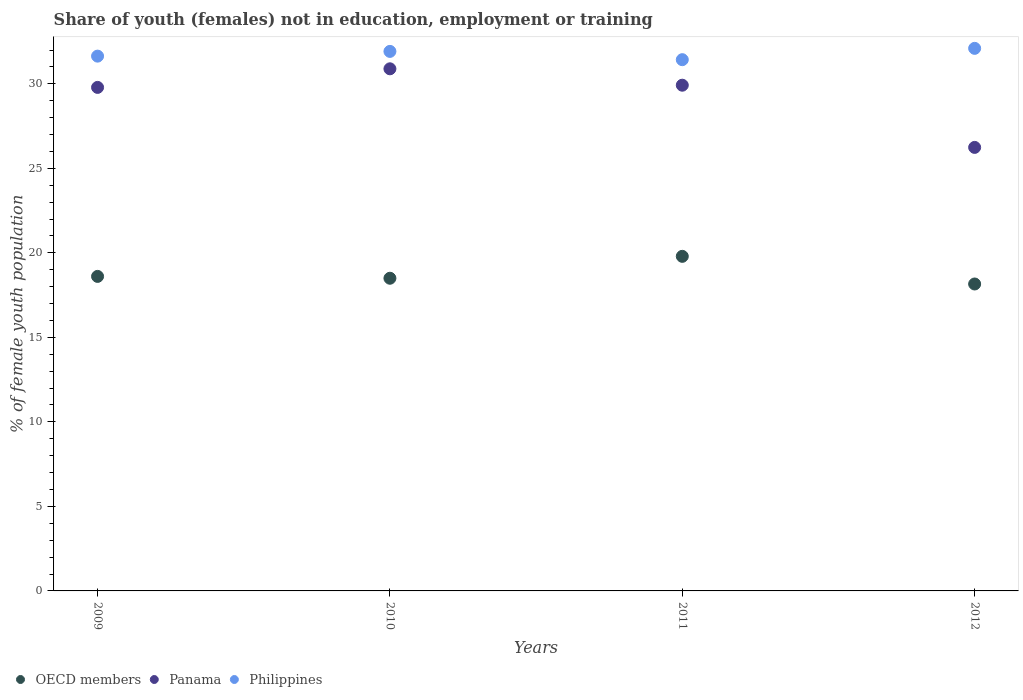How many different coloured dotlines are there?
Provide a short and direct response. 3. What is the percentage of unemployed female population in in OECD members in 2012?
Your answer should be compact. 18.16. Across all years, what is the maximum percentage of unemployed female population in in Panama?
Your answer should be compact. 30.89. Across all years, what is the minimum percentage of unemployed female population in in Philippines?
Give a very brief answer. 31.43. What is the total percentage of unemployed female population in in Philippines in the graph?
Make the answer very short. 127.09. What is the difference between the percentage of unemployed female population in in OECD members in 2011 and that in 2012?
Offer a very short reply. 1.64. What is the difference between the percentage of unemployed female population in in Philippines in 2012 and the percentage of unemployed female population in in Panama in 2009?
Provide a short and direct response. 2.31. What is the average percentage of unemployed female population in in OECD members per year?
Provide a succinct answer. 18.77. In the year 2009, what is the difference between the percentage of unemployed female population in in OECD members and percentage of unemployed female population in in Panama?
Make the answer very short. -11.18. In how many years, is the percentage of unemployed female population in in Philippines greater than 4 %?
Provide a succinct answer. 4. What is the ratio of the percentage of unemployed female population in in Philippines in 2011 to that in 2012?
Provide a succinct answer. 0.98. Is the difference between the percentage of unemployed female population in in OECD members in 2011 and 2012 greater than the difference between the percentage of unemployed female population in in Panama in 2011 and 2012?
Provide a succinct answer. No. What is the difference between the highest and the second highest percentage of unemployed female population in in Panama?
Provide a succinct answer. 0.97. What is the difference between the highest and the lowest percentage of unemployed female population in in Philippines?
Provide a succinct answer. 0.67. In how many years, is the percentage of unemployed female population in in OECD members greater than the average percentage of unemployed female population in in OECD members taken over all years?
Your response must be concise. 1. Is the sum of the percentage of unemployed female population in in Panama in 2009 and 2011 greater than the maximum percentage of unemployed female population in in Philippines across all years?
Keep it short and to the point. Yes. Does the percentage of unemployed female population in in Panama monotonically increase over the years?
Provide a short and direct response. No. How many dotlines are there?
Ensure brevity in your answer.  3. What is the difference between two consecutive major ticks on the Y-axis?
Keep it short and to the point. 5. Are the values on the major ticks of Y-axis written in scientific E-notation?
Your response must be concise. No. Does the graph contain any zero values?
Provide a short and direct response. No. Does the graph contain grids?
Provide a short and direct response. No. What is the title of the graph?
Your answer should be very brief. Share of youth (females) not in education, employment or training. What is the label or title of the Y-axis?
Provide a succinct answer. % of female youth population. What is the % of female youth population in OECD members in 2009?
Provide a succinct answer. 18.61. What is the % of female youth population in Panama in 2009?
Provide a short and direct response. 29.79. What is the % of female youth population in Philippines in 2009?
Provide a succinct answer. 31.64. What is the % of female youth population in OECD members in 2010?
Keep it short and to the point. 18.5. What is the % of female youth population in Panama in 2010?
Your response must be concise. 30.89. What is the % of female youth population in Philippines in 2010?
Your answer should be compact. 31.92. What is the % of female youth population of OECD members in 2011?
Offer a terse response. 19.8. What is the % of female youth population in Panama in 2011?
Your response must be concise. 29.92. What is the % of female youth population of Philippines in 2011?
Make the answer very short. 31.43. What is the % of female youth population of OECD members in 2012?
Your answer should be compact. 18.16. What is the % of female youth population of Panama in 2012?
Ensure brevity in your answer.  26.24. What is the % of female youth population in Philippines in 2012?
Offer a terse response. 32.1. Across all years, what is the maximum % of female youth population in OECD members?
Provide a succinct answer. 19.8. Across all years, what is the maximum % of female youth population in Panama?
Provide a succinct answer. 30.89. Across all years, what is the maximum % of female youth population of Philippines?
Make the answer very short. 32.1. Across all years, what is the minimum % of female youth population of OECD members?
Offer a very short reply. 18.16. Across all years, what is the minimum % of female youth population of Panama?
Your answer should be compact. 26.24. Across all years, what is the minimum % of female youth population of Philippines?
Your answer should be very brief. 31.43. What is the total % of female youth population in OECD members in the graph?
Provide a succinct answer. 75.06. What is the total % of female youth population of Panama in the graph?
Give a very brief answer. 116.84. What is the total % of female youth population in Philippines in the graph?
Your answer should be very brief. 127.09. What is the difference between the % of female youth population in OECD members in 2009 and that in 2010?
Provide a succinct answer. 0.11. What is the difference between the % of female youth population of Philippines in 2009 and that in 2010?
Offer a very short reply. -0.28. What is the difference between the % of female youth population of OECD members in 2009 and that in 2011?
Offer a terse response. -1.19. What is the difference between the % of female youth population in Panama in 2009 and that in 2011?
Offer a terse response. -0.13. What is the difference between the % of female youth population in Philippines in 2009 and that in 2011?
Your answer should be very brief. 0.21. What is the difference between the % of female youth population of OECD members in 2009 and that in 2012?
Ensure brevity in your answer.  0.45. What is the difference between the % of female youth population of Panama in 2009 and that in 2012?
Provide a short and direct response. 3.55. What is the difference between the % of female youth population of Philippines in 2009 and that in 2012?
Provide a succinct answer. -0.46. What is the difference between the % of female youth population of OECD members in 2010 and that in 2011?
Your answer should be compact. -1.3. What is the difference between the % of female youth population of Philippines in 2010 and that in 2011?
Your answer should be compact. 0.49. What is the difference between the % of female youth population in OECD members in 2010 and that in 2012?
Ensure brevity in your answer.  0.34. What is the difference between the % of female youth population in Panama in 2010 and that in 2012?
Offer a very short reply. 4.65. What is the difference between the % of female youth population in Philippines in 2010 and that in 2012?
Your answer should be compact. -0.18. What is the difference between the % of female youth population in OECD members in 2011 and that in 2012?
Make the answer very short. 1.64. What is the difference between the % of female youth population of Panama in 2011 and that in 2012?
Ensure brevity in your answer.  3.68. What is the difference between the % of female youth population in Philippines in 2011 and that in 2012?
Give a very brief answer. -0.67. What is the difference between the % of female youth population in OECD members in 2009 and the % of female youth population in Panama in 2010?
Offer a very short reply. -12.28. What is the difference between the % of female youth population in OECD members in 2009 and the % of female youth population in Philippines in 2010?
Your response must be concise. -13.31. What is the difference between the % of female youth population of Panama in 2009 and the % of female youth population of Philippines in 2010?
Give a very brief answer. -2.13. What is the difference between the % of female youth population in OECD members in 2009 and the % of female youth population in Panama in 2011?
Provide a succinct answer. -11.31. What is the difference between the % of female youth population in OECD members in 2009 and the % of female youth population in Philippines in 2011?
Provide a short and direct response. -12.82. What is the difference between the % of female youth population of Panama in 2009 and the % of female youth population of Philippines in 2011?
Provide a succinct answer. -1.64. What is the difference between the % of female youth population in OECD members in 2009 and the % of female youth population in Panama in 2012?
Give a very brief answer. -7.63. What is the difference between the % of female youth population in OECD members in 2009 and the % of female youth population in Philippines in 2012?
Your answer should be compact. -13.49. What is the difference between the % of female youth population in Panama in 2009 and the % of female youth population in Philippines in 2012?
Provide a succinct answer. -2.31. What is the difference between the % of female youth population in OECD members in 2010 and the % of female youth population in Panama in 2011?
Your answer should be very brief. -11.42. What is the difference between the % of female youth population of OECD members in 2010 and the % of female youth population of Philippines in 2011?
Keep it short and to the point. -12.93. What is the difference between the % of female youth population in Panama in 2010 and the % of female youth population in Philippines in 2011?
Ensure brevity in your answer.  -0.54. What is the difference between the % of female youth population in OECD members in 2010 and the % of female youth population in Panama in 2012?
Your answer should be compact. -7.74. What is the difference between the % of female youth population in OECD members in 2010 and the % of female youth population in Philippines in 2012?
Your answer should be compact. -13.6. What is the difference between the % of female youth population of Panama in 2010 and the % of female youth population of Philippines in 2012?
Give a very brief answer. -1.21. What is the difference between the % of female youth population in OECD members in 2011 and the % of female youth population in Panama in 2012?
Your response must be concise. -6.44. What is the difference between the % of female youth population in OECD members in 2011 and the % of female youth population in Philippines in 2012?
Your answer should be compact. -12.3. What is the difference between the % of female youth population in Panama in 2011 and the % of female youth population in Philippines in 2012?
Offer a terse response. -2.18. What is the average % of female youth population of OECD members per year?
Give a very brief answer. 18.77. What is the average % of female youth population of Panama per year?
Make the answer very short. 29.21. What is the average % of female youth population of Philippines per year?
Provide a succinct answer. 31.77. In the year 2009, what is the difference between the % of female youth population of OECD members and % of female youth population of Panama?
Provide a succinct answer. -11.18. In the year 2009, what is the difference between the % of female youth population of OECD members and % of female youth population of Philippines?
Keep it short and to the point. -13.03. In the year 2009, what is the difference between the % of female youth population in Panama and % of female youth population in Philippines?
Your response must be concise. -1.85. In the year 2010, what is the difference between the % of female youth population of OECD members and % of female youth population of Panama?
Ensure brevity in your answer.  -12.39. In the year 2010, what is the difference between the % of female youth population in OECD members and % of female youth population in Philippines?
Your answer should be compact. -13.42. In the year 2010, what is the difference between the % of female youth population of Panama and % of female youth population of Philippines?
Ensure brevity in your answer.  -1.03. In the year 2011, what is the difference between the % of female youth population of OECD members and % of female youth population of Panama?
Provide a succinct answer. -10.12. In the year 2011, what is the difference between the % of female youth population in OECD members and % of female youth population in Philippines?
Your answer should be compact. -11.63. In the year 2011, what is the difference between the % of female youth population of Panama and % of female youth population of Philippines?
Offer a terse response. -1.51. In the year 2012, what is the difference between the % of female youth population in OECD members and % of female youth population in Panama?
Your answer should be very brief. -8.08. In the year 2012, what is the difference between the % of female youth population of OECD members and % of female youth population of Philippines?
Ensure brevity in your answer.  -13.94. In the year 2012, what is the difference between the % of female youth population in Panama and % of female youth population in Philippines?
Make the answer very short. -5.86. What is the ratio of the % of female youth population in OECD members in 2009 to that in 2010?
Offer a terse response. 1.01. What is the ratio of the % of female youth population in Panama in 2009 to that in 2010?
Give a very brief answer. 0.96. What is the ratio of the % of female youth population in Philippines in 2009 to that in 2010?
Ensure brevity in your answer.  0.99. What is the ratio of the % of female youth population of OECD members in 2009 to that in 2012?
Provide a succinct answer. 1.02. What is the ratio of the % of female youth population of Panama in 2009 to that in 2012?
Your response must be concise. 1.14. What is the ratio of the % of female youth population in Philippines in 2009 to that in 2012?
Offer a terse response. 0.99. What is the ratio of the % of female youth population of OECD members in 2010 to that in 2011?
Provide a succinct answer. 0.93. What is the ratio of the % of female youth population of Panama in 2010 to that in 2011?
Your response must be concise. 1.03. What is the ratio of the % of female youth population in Philippines in 2010 to that in 2011?
Ensure brevity in your answer.  1.02. What is the ratio of the % of female youth population of OECD members in 2010 to that in 2012?
Your answer should be compact. 1.02. What is the ratio of the % of female youth population of Panama in 2010 to that in 2012?
Give a very brief answer. 1.18. What is the ratio of the % of female youth population in OECD members in 2011 to that in 2012?
Offer a terse response. 1.09. What is the ratio of the % of female youth population in Panama in 2011 to that in 2012?
Ensure brevity in your answer.  1.14. What is the ratio of the % of female youth population in Philippines in 2011 to that in 2012?
Your answer should be very brief. 0.98. What is the difference between the highest and the second highest % of female youth population of OECD members?
Your answer should be very brief. 1.19. What is the difference between the highest and the second highest % of female youth population of Philippines?
Keep it short and to the point. 0.18. What is the difference between the highest and the lowest % of female youth population of OECD members?
Ensure brevity in your answer.  1.64. What is the difference between the highest and the lowest % of female youth population of Panama?
Your response must be concise. 4.65. What is the difference between the highest and the lowest % of female youth population in Philippines?
Your response must be concise. 0.67. 